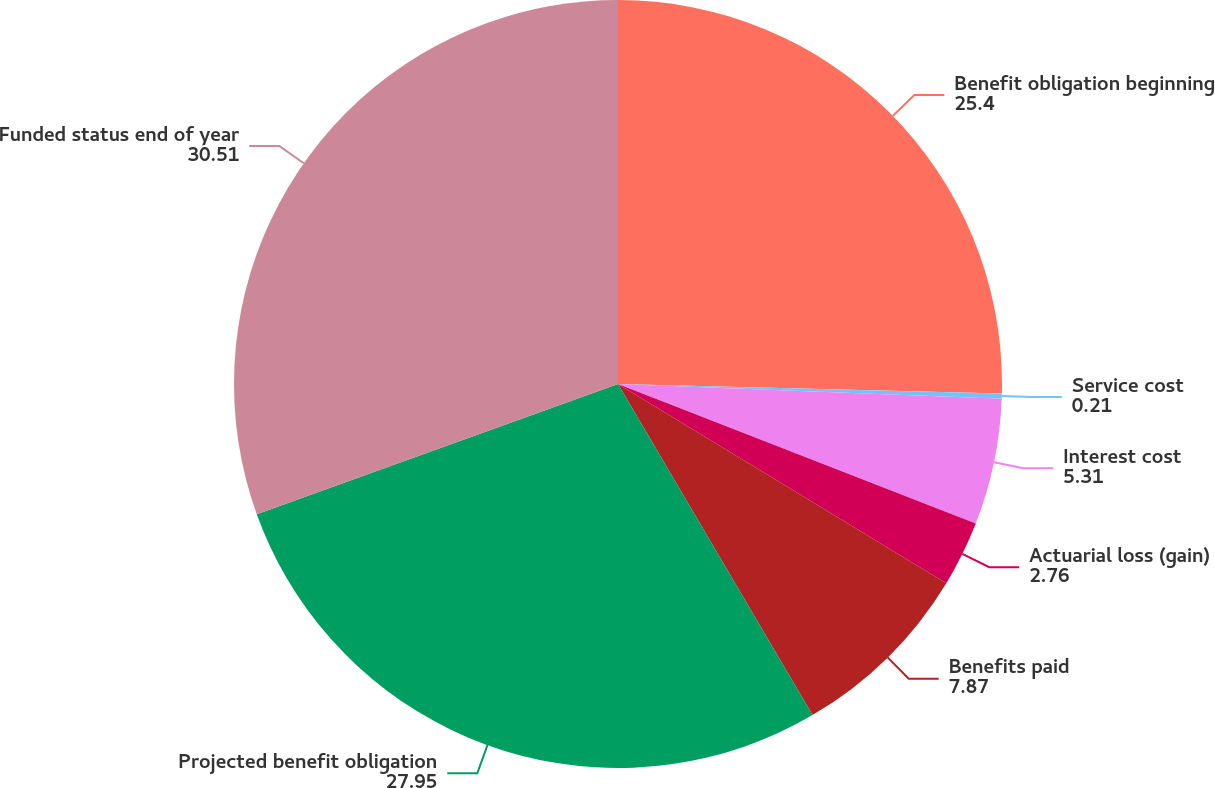Convert chart to OTSL. <chart><loc_0><loc_0><loc_500><loc_500><pie_chart><fcel>Benefit obligation beginning<fcel>Service cost<fcel>Interest cost<fcel>Actuarial loss (gain)<fcel>Benefits paid<fcel>Projected benefit obligation<fcel>Funded status end of year<nl><fcel>25.4%<fcel>0.21%<fcel>5.31%<fcel>2.76%<fcel>7.87%<fcel>27.95%<fcel>30.51%<nl></chart> 